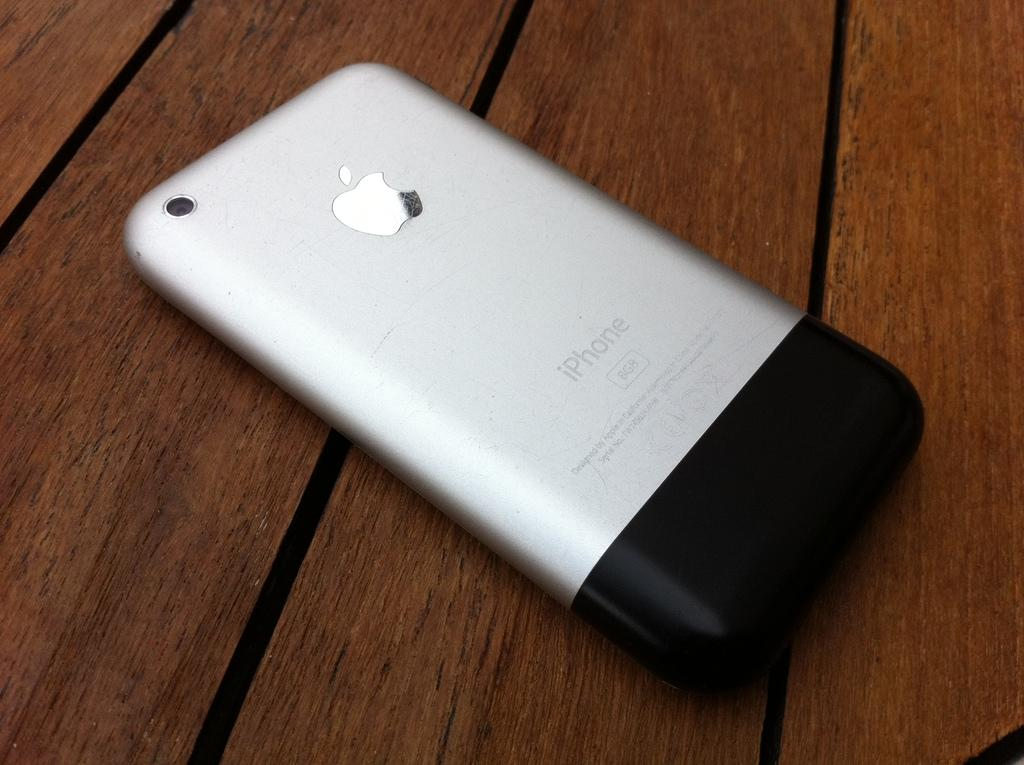<image>
Share a concise interpretation of the image provided. looks like the back of an iphone turned around on a table 